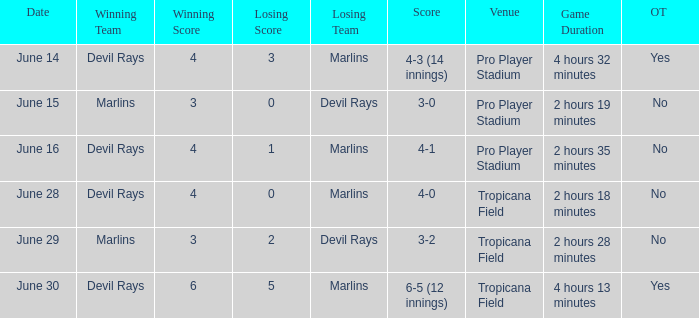What was the score on june 29? 3-2. 